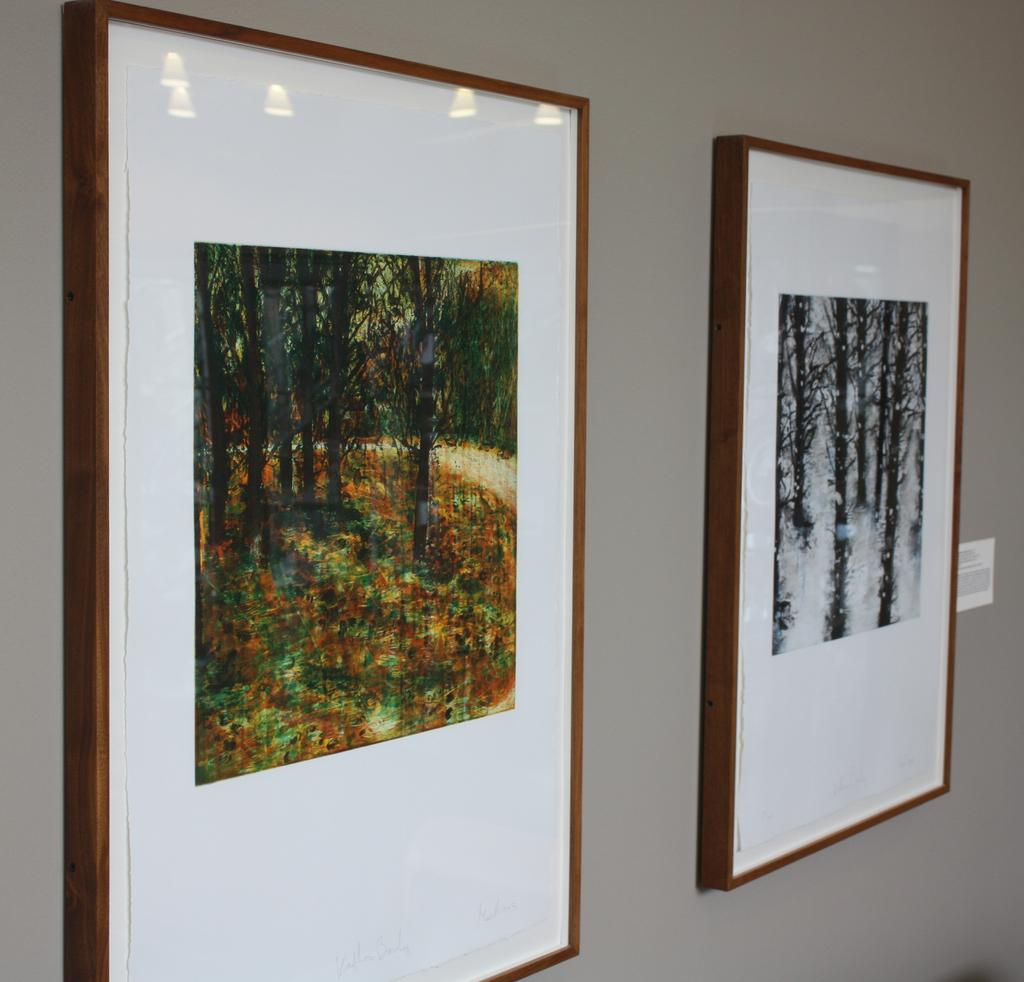What is hanging on the wall in the image? There are frames on the wall in the image. What can be seen inside the frames? The frames contain images of trees. What type of watch is visible in the image? There is no watch present in the image. How does the beginner artist create the scene in the image? The image does not depict a scene being created by an artist, nor does it indicate the skill level of any artist involved. 